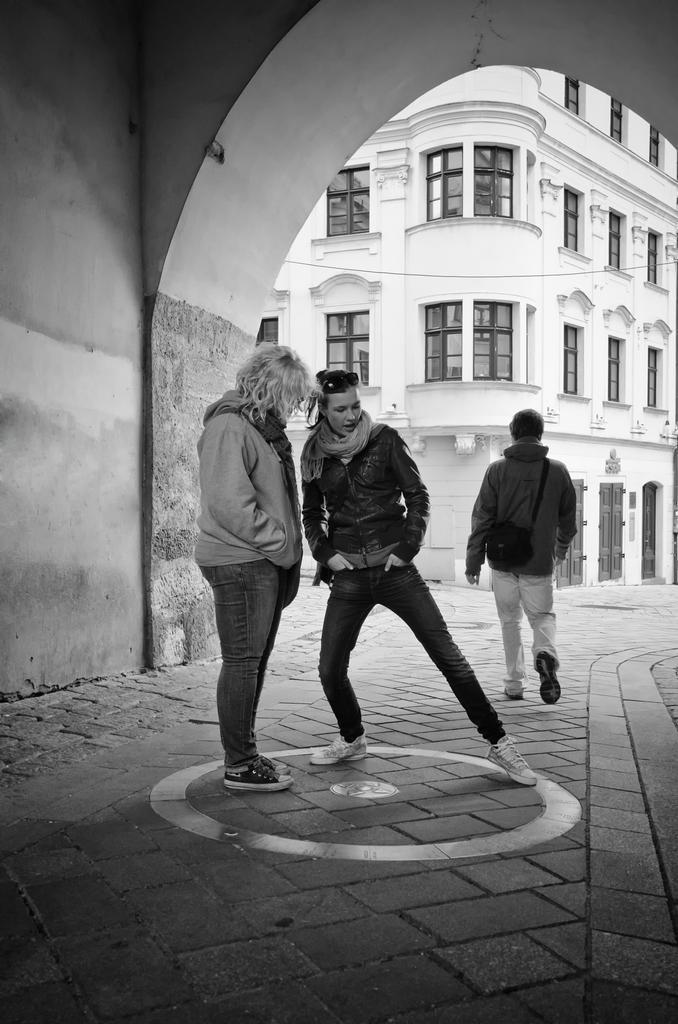How would you summarize this image in a sentence or two? In this picture we can see three persons where two are standing and a person walking on the road and in the background we can see a building with windows. 